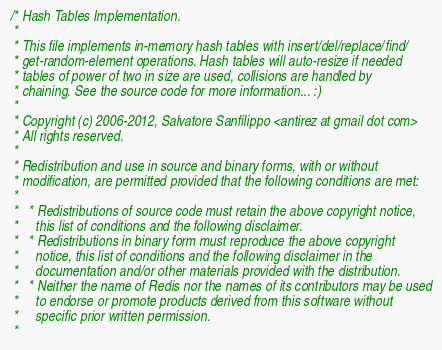Convert code to text. <code><loc_0><loc_0><loc_500><loc_500><_C_>/* Hash Tables Implementation.
 *
 * This file implements in-memory hash tables with insert/del/replace/find/
 * get-random-element operations. Hash tables will auto-resize if needed
 * tables of power of two in size are used, collisions are handled by
 * chaining. See the source code for more information... :)
 *
 * Copyright (c) 2006-2012, Salvatore Sanfilippo <antirez at gmail dot com>
 * All rights reserved.
 *
 * Redistribution and use in source and binary forms, with or without
 * modification, are permitted provided that the following conditions are met:
 *
 *   * Redistributions of source code must retain the above copyright notice,
 *     this list of conditions and the following disclaimer.
 *   * Redistributions in binary form must reproduce the above copyright
 *     notice, this list of conditions and the following disclaimer in the
 *     documentation and/or other materials provided with the distribution.
 *   * Neither the name of Redis nor the names of its contributors may be used
 *     to endorse or promote products derived from this software without
 *     specific prior written permission.
 *</code> 